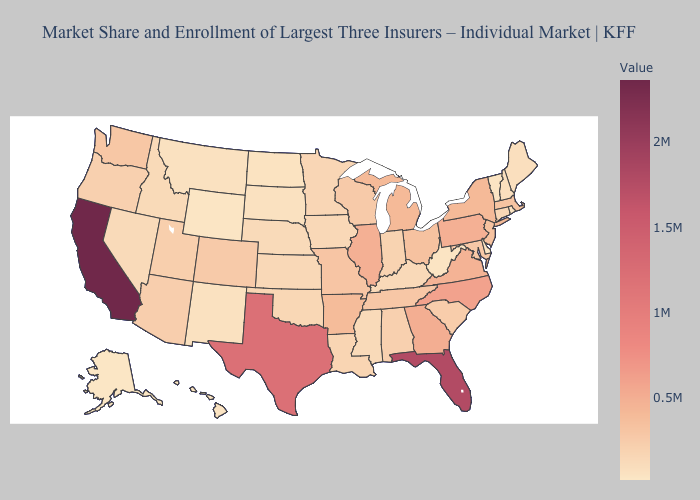Does the map have missing data?
Write a very short answer. No. Does Pennsylvania have the lowest value in the Northeast?
Be succinct. No. Which states have the highest value in the USA?
Short answer required. California. Does California have the highest value in the USA?
Keep it brief. Yes. 